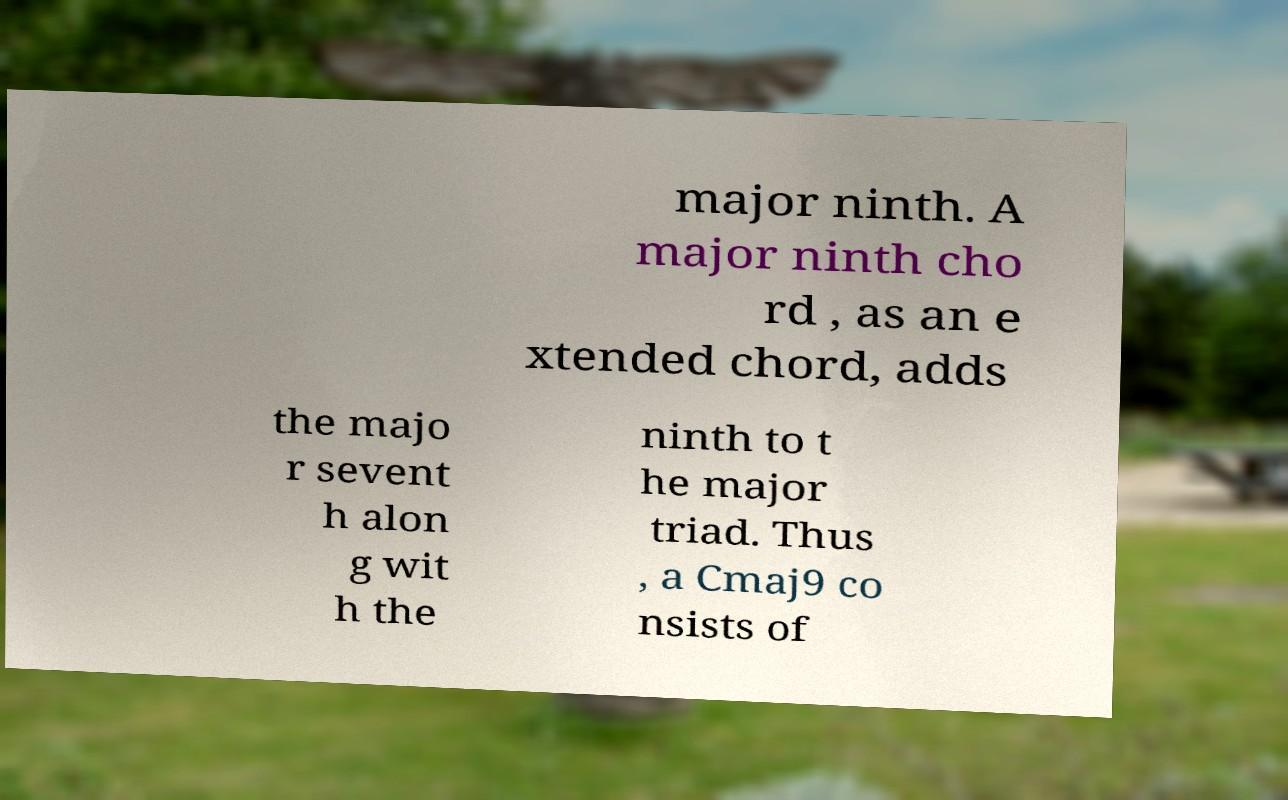Could you assist in decoding the text presented in this image and type it out clearly? major ninth. A major ninth cho rd , as an e xtended chord, adds the majo r sevent h alon g wit h the ninth to t he major triad. Thus , a Cmaj9 co nsists of 